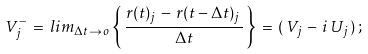Convert formula to latex. <formula><loc_0><loc_0><loc_500><loc_500>V _ { j } ^ { - } \, = \, l i m _ { \Delta t \to \, o } \left \{ \, \frac { r ( t ) _ { j } \, - \, r ( t - \Delta t ) _ { j } \, } { \Delta t } \, \right \} \, = \, ( \, V _ { j } \, - \, i \, U _ { j } \, ) \, ;</formula> 